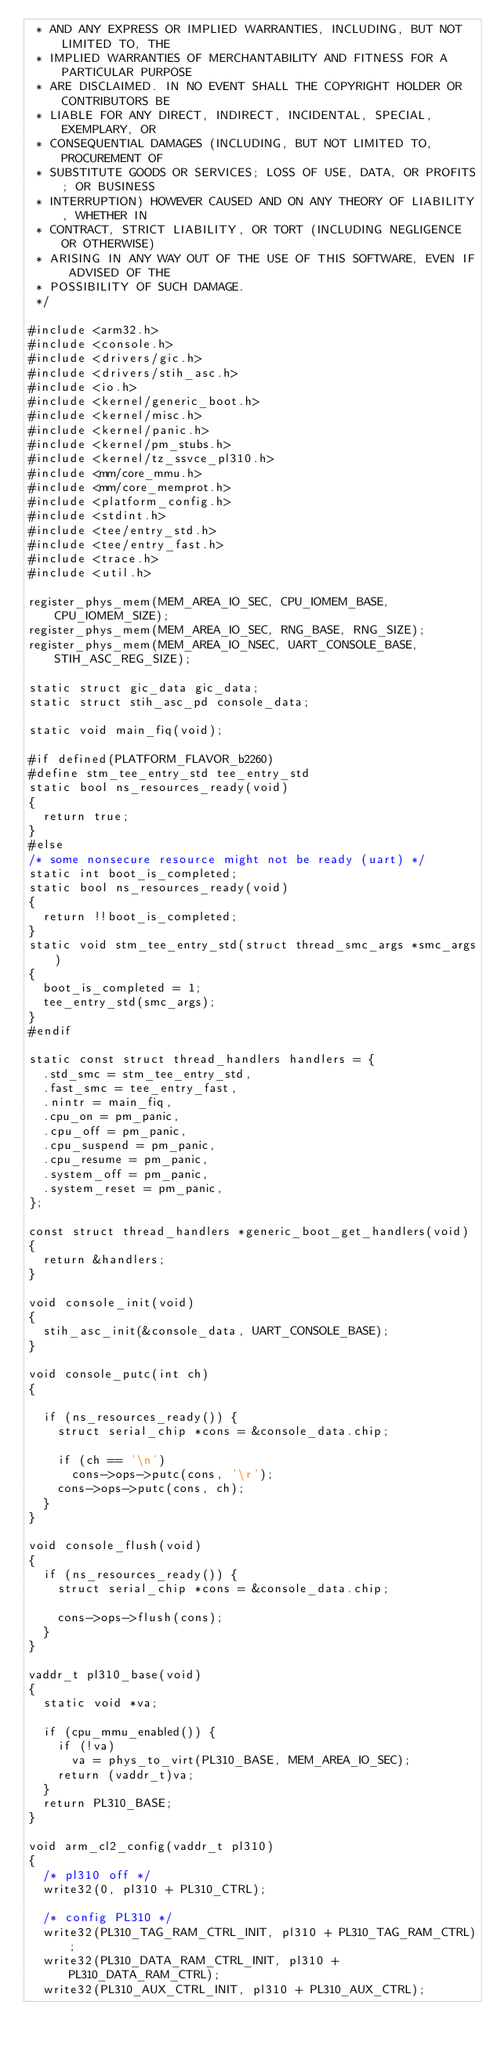<code> <loc_0><loc_0><loc_500><loc_500><_C_> * AND ANY EXPRESS OR IMPLIED WARRANTIES, INCLUDING, BUT NOT LIMITED TO, THE
 * IMPLIED WARRANTIES OF MERCHANTABILITY AND FITNESS FOR A PARTICULAR PURPOSE
 * ARE DISCLAIMED. IN NO EVENT SHALL THE COPYRIGHT HOLDER OR CONTRIBUTORS BE
 * LIABLE FOR ANY DIRECT, INDIRECT, INCIDENTAL, SPECIAL, EXEMPLARY, OR
 * CONSEQUENTIAL DAMAGES (INCLUDING, BUT NOT LIMITED TO, PROCUREMENT OF
 * SUBSTITUTE GOODS OR SERVICES; LOSS OF USE, DATA, OR PROFITS; OR BUSINESS
 * INTERRUPTION) HOWEVER CAUSED AND ON ANY THEORY OF LIABILITY, WHETHER IN
 * CONTRACT, STRICT LIABILITY, OR TORT (INCLUDING NEGLIGENCE OR OTHERWISE)
 * ARISING IN ANY WAY OUT OF THE USE OF THIS SOFTWARE, EVEN IF ADVISED OF THE
 * POSSIBILITY OF SUCH DAMAGE.
 */

#include <arm32.h>
#include <console.h>
#include <drivers/gic.h>
#include <drivers/stih_asc.h>
#include <io.h>
#include <kernel/generic_boot.h>
#include <kernel/misc.h>
#include <kernel/panic.h>
#include <kernel/pm_stubs.h>
#include <kernel/tz_ssvce_pl310.h>
#include <mm/core_mmu.h>
#include <mm/core_memprot.h>
#include <platform_config.h>
#include <stdint.h>
#include <tee/entry_std.h>
#include <tee/entry_fast.h>
#include <trace.h>
#include <util.h>

register_phys_mem(MEM_AREA_IO_SEC, CPU_IOMEM_BASE, CPU_IOMEM_SIZE);
register_phys_mem(MEM_AREA_IO_SEC, RNG_BASE, RNG_SIZE);
register_phys_mem(MEM_AREA_IO_NSEC, UART_CONSOLE_BASE, STIH_ASC_REG_SIZE);

static struct gic_data gic_data;
static struct stih_asc_pd console_data;

static void main_fiq(void);

#if defined(PLATFORM_FLAVOR_b2260)
#define stm_tee_entry_std	tee_entry_std
static bool ns_resources_ready(void)
{
	return true;
}
#else
/* some nonsecure resource might not be ready (uart) */
static int boot_is_completed;
static bool ns_resources_ready(void)
{
	return !!boot_is_completed;
}
static void stm_tee_entry_std(struct thread_smc_args *smc_args)
{
	boot_is_completed = 1;
	tee_entry_std(smc_args);
}
#endif

static const struct thread_handlers handlers = {
	.std_smc = stm_tee_entry_std,
	.fast_smc = tee_entry_fast,
	.nintr = main_fiq,
	.cpu_on = pm_panic,
	.cpu_off = pm_panic,
	.cpu_suspend = pm_panic,
	.cpu_resume = pm_panic,
	.system_off = pm_panic,
	.system_reset = pm_panic,
};

const struct thread_handlers *generic_boot_get_handlers(void)
{
	return &handlers;
}

void console_init(void)
{
	stih_asc_init(&console_data, UART_CONSOLE_BASE);
}

void console_putc(int ch)
{

	if (ns_resources_ready()) {
		struct serial_chip *cons = &console_data.chip;

		if (ch == '\n')
			cons->ops->putc(cons, '\r');
		cons->ops->putc(cons, ch);
	}
}

void console_flush(void)
{
	if (ns_resources_ready()) {
		struct serial_chip *cons = &console_data.chip;

		cons->ops->flush(cons);
	}
}

vaddr_t pl310_base(void)
{
	static void *va;

	if (cpu_mmu_enabled()) {
		if (!va)
			va = phys_to_virt(PL310_BASE, MEM_AREA_IO_SEC);
		return (vaddr_t)va;
	}
	return PL310_BASE;
}

void arm_cl2_config(vaddr_t pl310)
{
	/* pl310 off */
	write32(0, pl310 + PL310_CTRL);

	/* config PL310 */
	write32(PL310_TAG_RAM_CTRL_INIT, pl310 + PL310_TAG_RAM_CTRL);
	write32(PL310_DATA_RAM_CTRL_INIT, pl310 + PL310_DATA_RAM_CTRL);
	write32(PL310_AUX_CTRL_INIT, pl310 + PL310_AUX_CTRL);</code> 